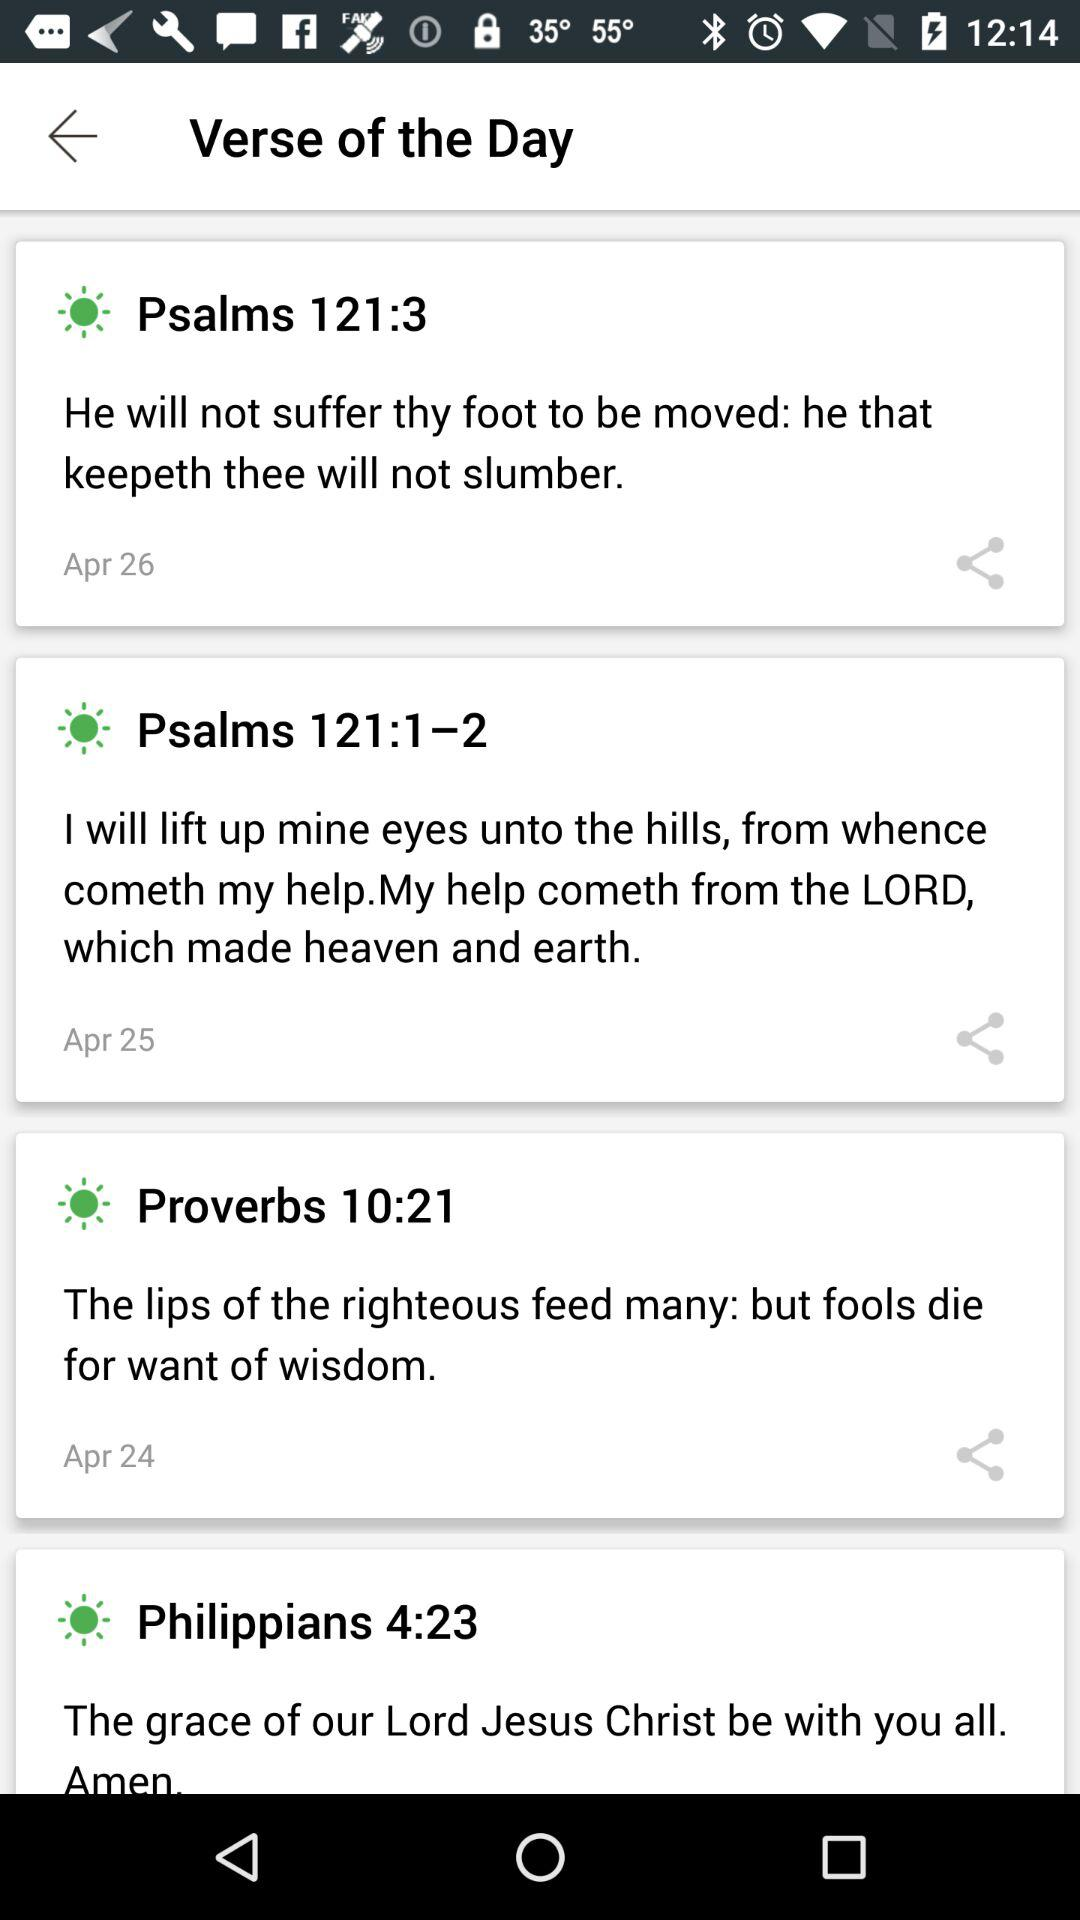How many verses are shown in this screen?
Answer the question using a single word or phrase. 4 